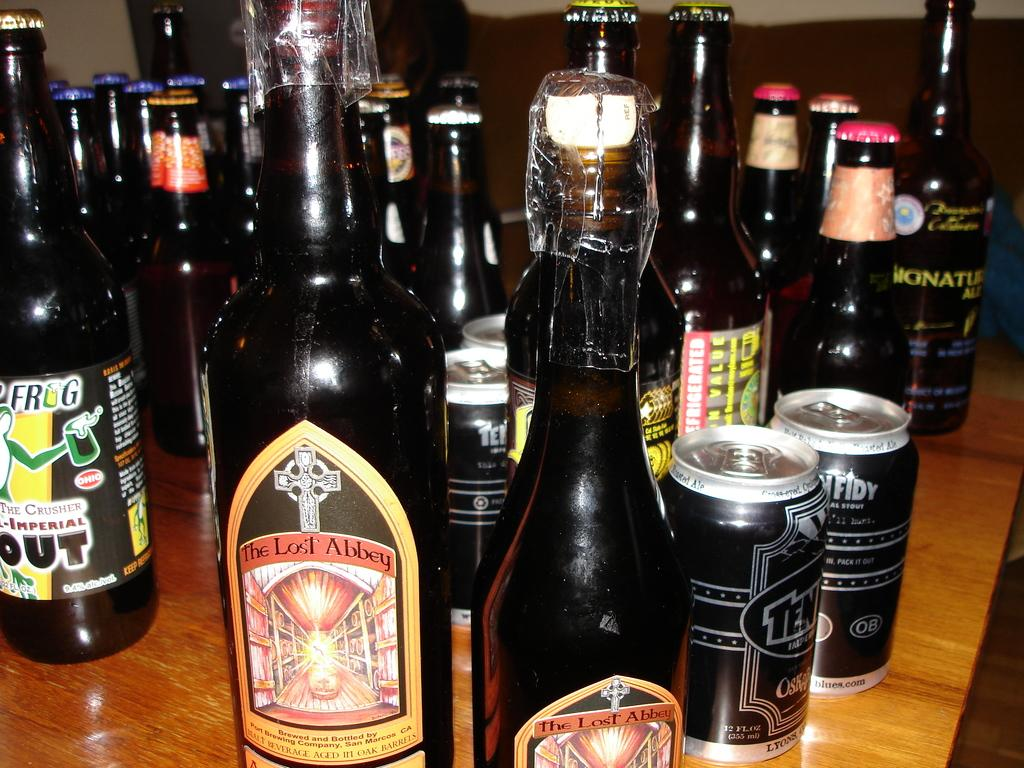<image>
Summarize the visual content of the image. A two bottles of The Lost Abbey is next to a bottle with a frog on the label. 